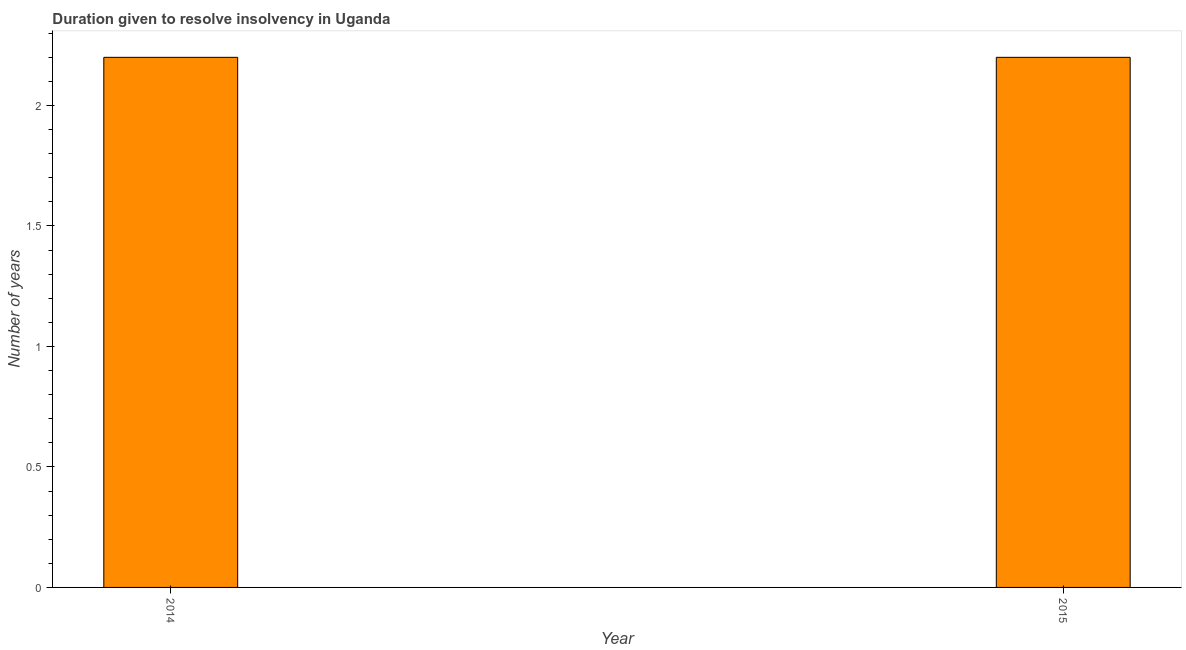Does the graph contain any zero values?
Offer a very short reply. No. What is the title of the graph?
Your response must be concise. Duration given to resolve insolvency in Uganda. What is the label or title of the X-axis?
Give a very brief answer. Year. What is the label or title of the Y-axis?
Give a very brief answer. Number of years. What is the number of years to resolve insolvency in 2014?
Offer a terse response. 2.2. In which year was the number of years to resolve insolvency minimum?
Your answer should be very brief. 2014. What is the sum of the number of years to resolve insolvency?
Keep it short and to the point. 4.4. What is the difference between the number of years to resolve insolvency in 2014 and 2015?
Give a very brief answer. 0. What is the average number of years to resolve insolvency per year?
Provide a succinct answer. 2.2. What is the median number of years to resolve insolvency?
Offer a terse response. 2.2. Is the number of years to resolve insolvency in 2014 less than that in 2015?
Provide a short and direct response. No. In how many years, is the number of years to resolve insolvency greater than the average number of years to resolve insolvency taken over all years?
Your answer should be compact. 0. Are all the bars in the graph horizontal?
Keep it short and to the point. No. What is the difference between two consecutive major ticks on the Y-axis?
Offer a very short reply. 0.5. What is the Number of years of 2014?
Ensure brevity in your answer.  2.2. What is the difference between the Number of years in 2014 and 2015?
Your answer should be compact. 0. What is the ratio of the Number of years in 2014 to that in 2015?
Offer a very short reply. 1. 